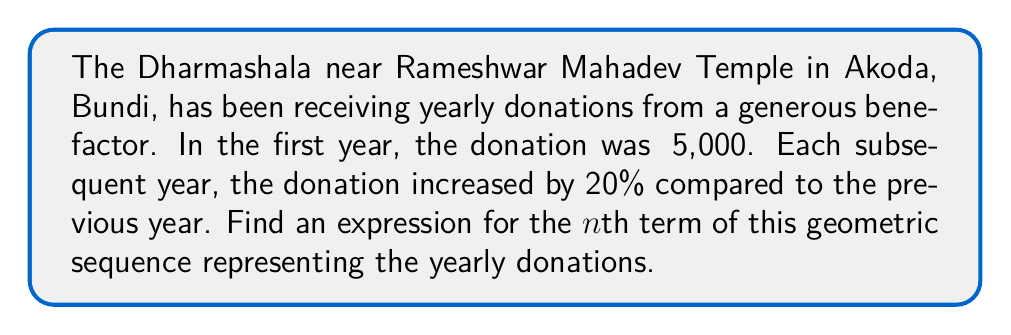Can you solve this math problem? To find the nth term of a geometric sequence, we need to identify the first term and the common ratio.

1. First term (a): ₹5,000 or 5000

2. Common ratio (r): The donation increases by 20% each year, so:
   $r = 1 + 0.20 = 1.20$

3. The general formula for the nth term of a geometric sequence is:
   $a_n = a \cdot r^{n-1}$

   Where:
   $a_n$ is the nth term
   $a$ is the first term
   $r$ is the common ratio
   $n$ is the term number

4. Substituting our values:
   $a_n = 5000 \cdot (1.20)^{n-1}$

5. Simplify:
   $a_n = 5000 \cdot 1.20^{n-1}$

This expression represents the donation amount for any given year n.
Answer: $a_n = 5000 \cdot 1.20^{n-1}$ 